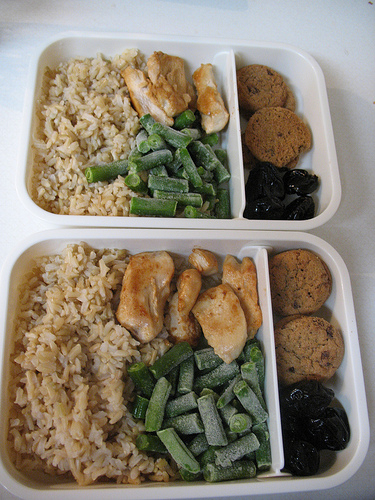<image>
Is the plate under the food? Yes. The plate is positioned underneath the food, with the food above it in the vertical space. 